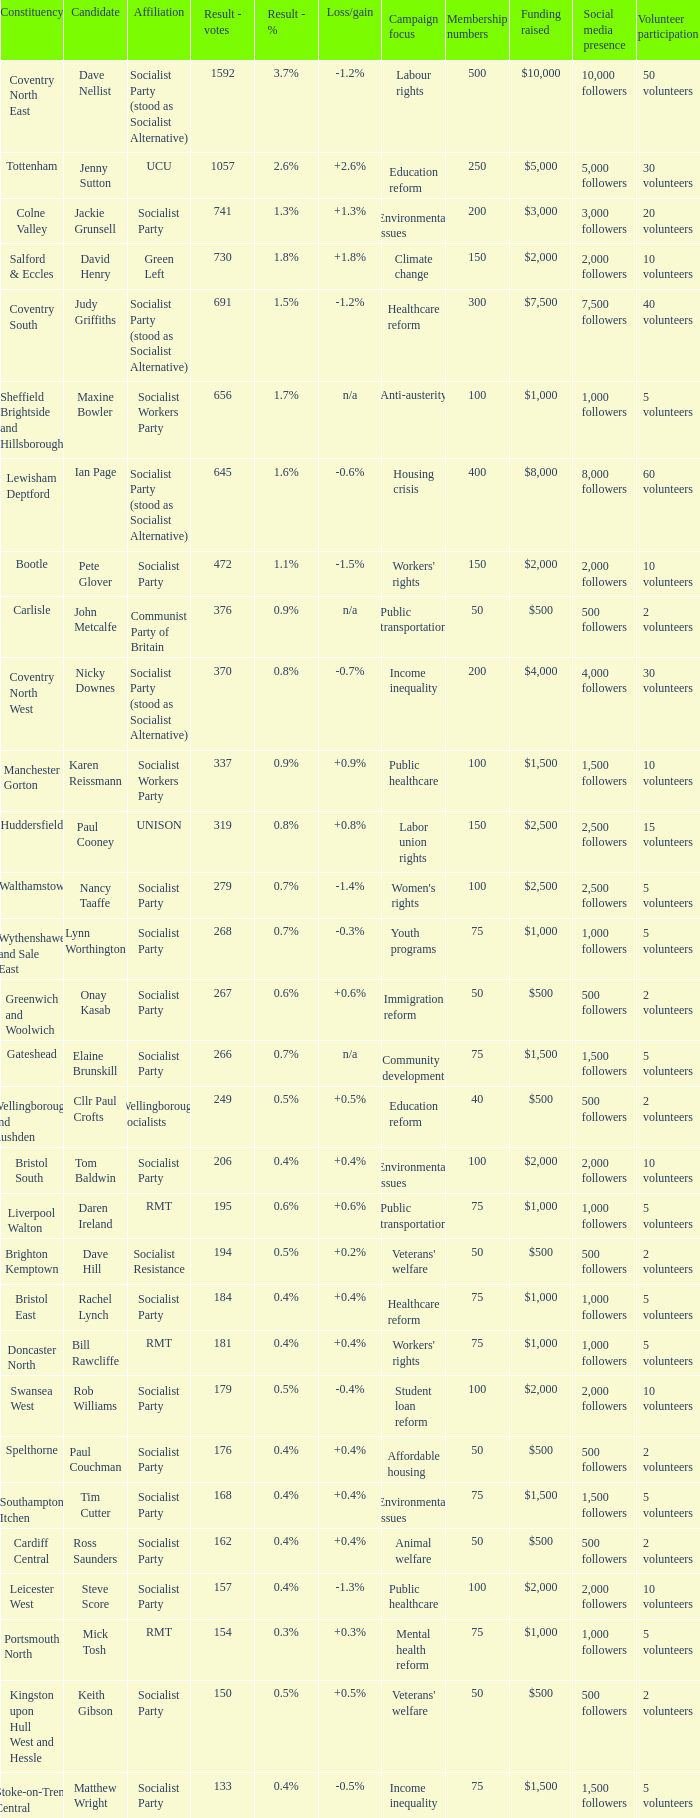What are all the nominees for the cardiff central constituency? Ross Saunders. Would you mind parsing the complete table? {'header': ['Constituency', 'Candidate', 'Affiliation', 'Result - votes', 'Result - %', 'Loss/gain', 'Campaign focus', 'Membership numbers', 'Funding raised', 'Social media presence', 'Volunteer participation'], 'rows': [['Coventry North East', 'Dave Nellist', 'Socialist Party (stood as Socialist Alternative)', '1592', '3.7%', '-1.2%', 'Labour rights', '500', '$10,000', '10,000 followers', '50 volunteers'], ['Tottenham', 'Jenny Sutton', 'UCU', '1057', '2.6%', '+2.6%', 'Education reform', '250', '$5,000', '5,000 followers', '30 volunteers'], ['Colne Valley', 'Jackie Grunsell', 'Socialist Party', '741', '1.3%', '+1.3%', 'Environmental issues', '200', '$3,000', '3,000 followers', '20 volunteers'], ['Salford & Eccles', 'David Henry', 'Green Left', '730', '1.8%', '+1.8%', 'Climate change', '150', '$2,000', '2,000 followers', '10 volunteers'], ['Coventry South', 'Judy Griffiths', 'Socialist Party (stood as Socialist Alternative)', '691', '1.5%', '-1.2%', 'Healthcare reform', '300', '$7,500', '7,500 followers', '40 volunteers'], ['Sheffield Brightside and Hillsborough', 'Maxine Bowler', 'Socialist Workers Party', '656', '1.7%', 'n/a', 'Anti-austerity', '100', '$1,000', '1,000 followers', '5 volunteers'], ['Lewisham Deptford', 'Ian Page', 'Socialist Party (stood as Socialist Alternative)', '645', '1.6%', '-0.6%', 'Housing crisis', '400', '$8,000', '8,000 followers', '60 volunteers'], ['Bootle', 'Pete Glover', 'Socialist Party', '472', '1.1%', '-1.5%', "Workers' rights", '150', '$2,000', '2,000 followers', '10 volunteers'], ['Carlisle', 'John Metcalfe', 'Communist Party of Britain', '376', '0.9%', 'n/a', 'Public transportation', '50', '$500', '500 followers', '2 volunteers'], ['Coventry North West', 'Nicky Downes', 'Socialist Party (stood as Socialist Alternative)', '370', '0.8%', '-0.7%', 'Income inequality', '200', '$4,000', '4,000 followers', '30 volunteers'], ['Manchester Gorton', 'Karen Reissmann', 'Socialist Workers Party', '337', '0.9%', '+0.9%', 'Public healthcare', '100', '$1,500', '1,500 followers', '10 volunteers'], ['Huddersfield', 'Paul Cooney', 'UNISON', '319', '0.8%', '+0.8%', 'Labor union rights', '150', '$2,500', '2,500 followers', '15 volunteers'], ['Walthamstow', 'Nancy Taaffe', 'Socialist Party', '279', '0.7%', '-1.4%', "Women's rights", '100', '$2,500', '2,500 followers', '5 volunteers'], ['Wythenshawe and Sale East', 'Lynn Worthington', 'Socialist Party', '268', '0.7%', '-0.3%', 'Youth programs', '75', '$1,000', '1,000 followers', '5 volunteers'], ['Greenwich and Woolwich', 'Onay Kasab', 'Socialist Party', '267', '0.6%', '+0.6%', 'Immigration reform', '50', '$500', '500 followers', '2 volunteers'], ['Gateshead', 'Elaine Brunskill', 'Socialist Party', '266', '0.7%', 'n/a', 'Community development', '75', '$1,500', '1,500 followers', '5 volunteers'], ['Wellingborough and Rushden', 'Cllr Paul Crofts', 'Wellingborough Socialists', '249', '0.5%', '+0.5%', 'Education reform', '40', '$500', '500 followers', '2 volunteers'], ['Bristol South', 'Tom Baldwin', 'Socialist Party', '206', '0.4%', '+0.4%', 'Environmental issues', '100', '$2,000', '2,000 followers', '10 volunteers'], ['Liverpool Walton', 'Daren Ireland', 'RMT', '195', '0.6%', '+0.6%', 'Public transportation', '75', '$1,000', '1,000 followers', '5 volunteers'], ['Brighton Kemptown', 'Dave Hill', 'Socialist Resistance', '194', '0.5%', '+0.2%', "Veterans' welfare", '50', '$500', '500 followers', '2 volunteers'], ['Bristol East', 'Rachel Lynch', 'Socialist Party', '184', '0.4%', '+0.4%', 'Healthcare reform', '75', '$1,000', '1,000 followers', '5 volunteers'], ['Doncaster North', 'Bill Rawcliffe', 'RMT', '181', '0.4%', '+0.4%', "Workers' rights", '75', '$1,000', '1,000 followers', '5 volunteers'], ['Swansea West', 'Rob Williams', 'Socialist Party', '179', '0.5%', '-0.4%', 'Student loan reform', '100', '$2,000', '2,000 followers', '10 volunteers'], ['Spelthorne', 'Paul Couchman', 'Socialist Party', '176', '0.4%', '+0.4%', 'Affordable housing', '50', '$500', '500 followers', '2 volunteers'], ['Southampton Itchen', 'Tim Cutter', 'Socialist Party', '168', '0.4%', '+0.4%', 'Environmental issues', '75', '$1,500', '1,500 followers', '5 volunteers'], ['Cardiff Central', 'Ross Saunders', 'Socialist Party', '162', '0.4%', '+0.4%', 'Animal welfare', '50', '$500', '500 followers', '2 volunteers'], ['Leicester West', 'Steve Score', 'Socialist Party', '157', '0.4%', '-1.3%', 'Public healthcare', '100', '$2,000', '2,000 followers', '10 volunteers'], ['Portsmouth North', 'Mick Tosh', 'RMT', '154', '0.3%', '+0.3%', 'Mental health reform', '75', '$1,000', '1,000 followers', '5 volunteers'], ['Kingston upon Hull West and Hessle', 'Keith Gibson', 'Socialist Party', '150', '0.5%', '+0.5%', "Veterans' welfare", '50', '$500', '500 followers', '2 volunteers'], ['Stoke-on-Trent Central', 'Matthew Wright', 'Socialist Party', '133', '0.4%', '-0.5%', 'Income inequality', '75', '$1,500', '1,500 followers', '5 volunteers']]} 